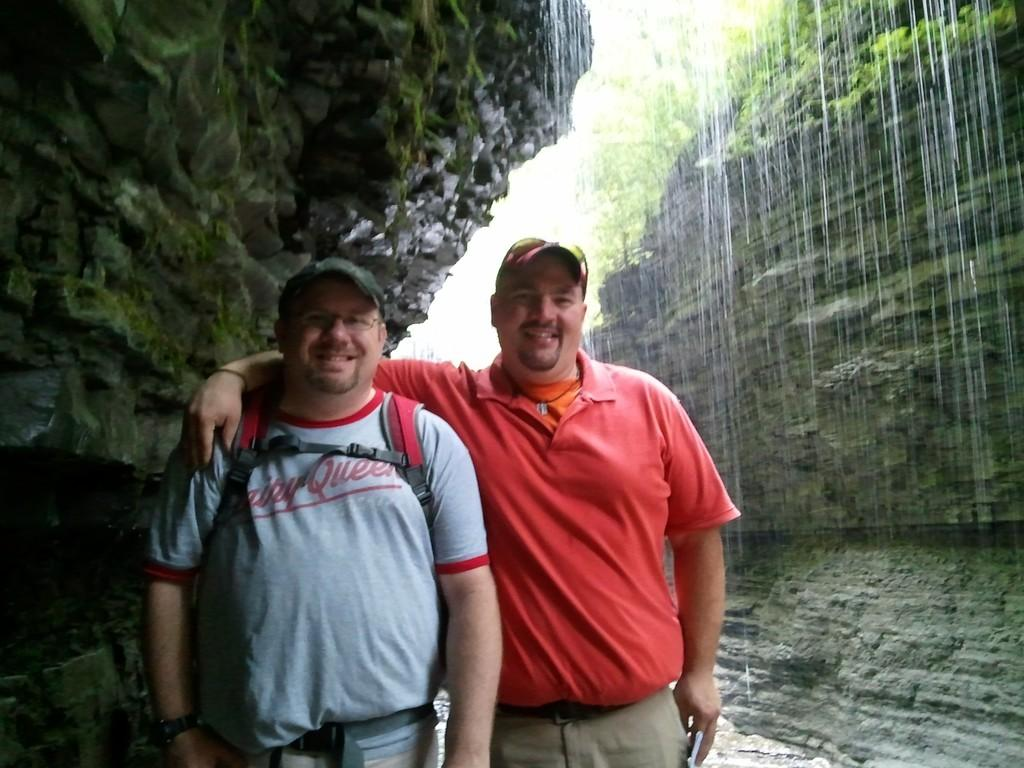Provide a one-sentence caption for the provided image. Two men pose for a picture under a waterfall, while the man on the left wears a shirt saying Dairy Queen. 